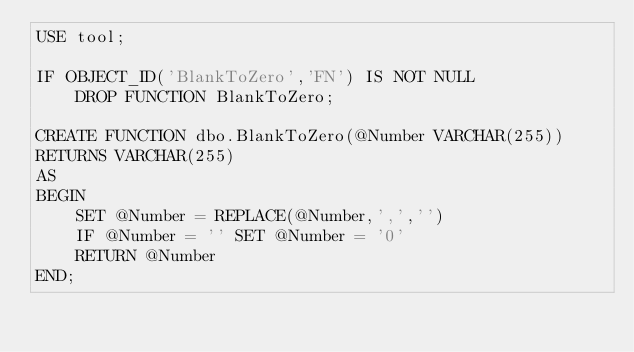<code> <loc_0><loc_0><loc_500><loc_500><_SQL_>USE tool;

IF OBJECT_ID('BlankToZero','FN') IS NOT NULL
    DROP FUNCTION BlankToZero;

CREATE FUNCTION dbo.BlankToZero(@Number VARCHAR(255))
RETURNS VARCHAR(255)
AS
BEGIN
    SET @Number = REPLACE(@Number,',','')
    IF @Number = '' SET @Number = '0'
    RETURN @Number
END;
</code> 